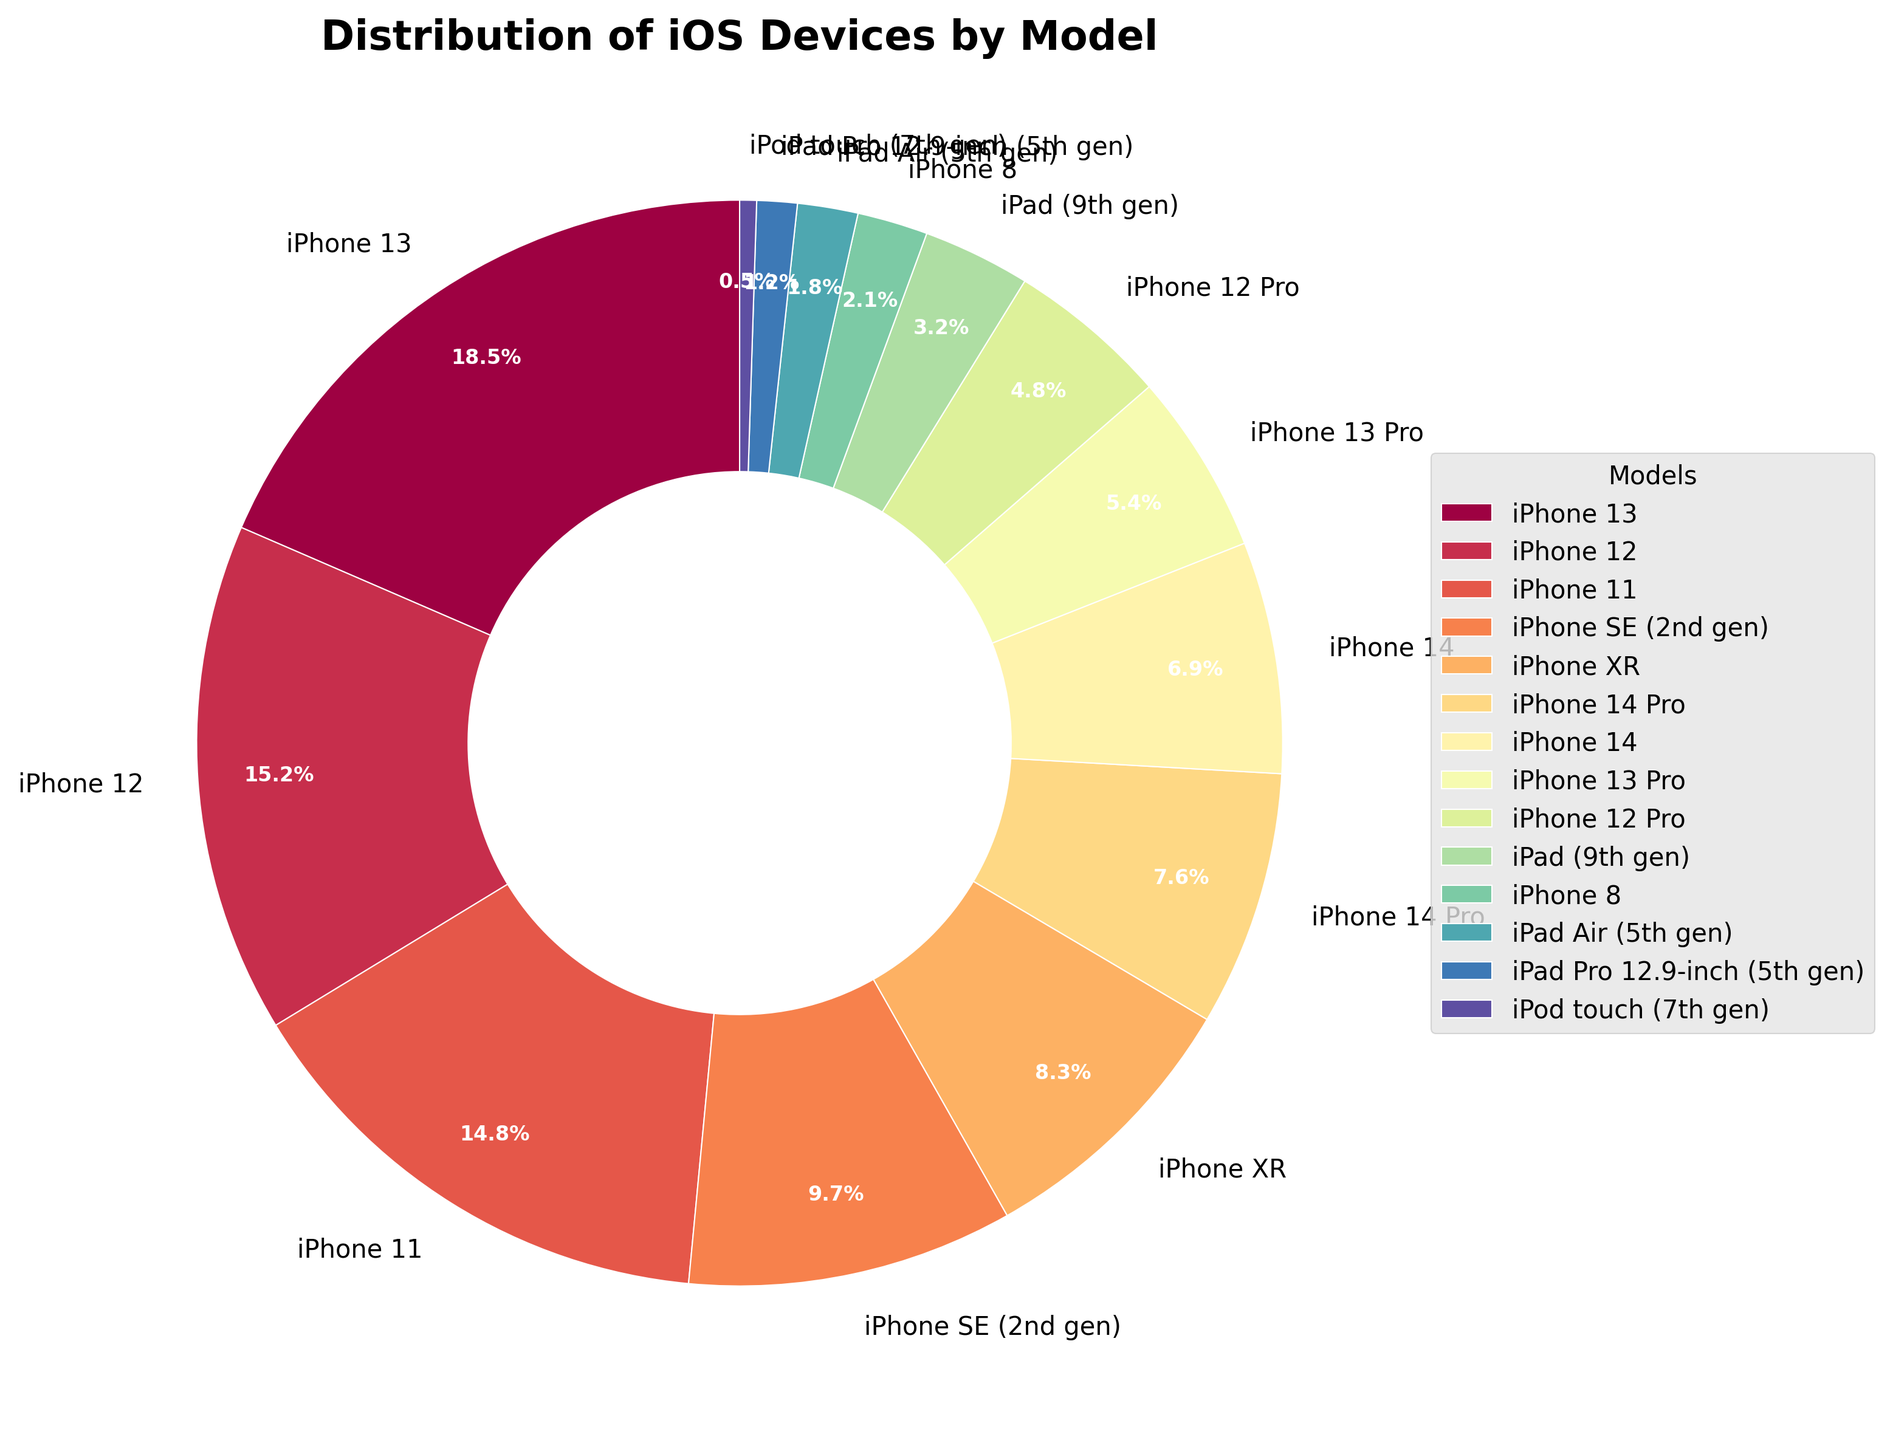Which iPhone model has the highest market share? The iPhone model with the highest market share can be identified by looking for the largest wedge in the pie chart. The largest wedge represents the iPhone 13 with 18.5%.
Answer: iPhone 13 What is the combined market share of iPhone 12 and iPhone 11? To find the combined market share, add the percentages of the iPhone 12 and iPhone 11. The iPhone 12 has 15.2%, and the iPhone 11 has 14.8%. So, 15.2% + 14.8% = 30%.
Answer: 30% Which model has a larger market share: iPhone SE (2nd gen) or iPhone XR? Compare the percentages of the iPhone SE (2nd gen) and iPhone XR. The iPhone SE (2nd gen) has 9.7%, and the iPhone XR has 8.3%. Since 9.7% > 8.3%, the iPhone SE (2nd gen) has a larger market share.
Answer: iPhone SE (2nd gen) What's the difference in market share between the iPhone 14 and iPhone 14 Pro? Subtract the market share of the iPhone 14 from the iPhone 14 Pro. The iPhone 14 has 6.9%, and the iPhone 14 Pro has 7.6%. So, 7.6% - 6.9% = 0.7%.
Answer: 0.7% How many models have a market share less than 5%? Check the percentages on the pie chart for models that have a market share smaller than 5%. The models are iPhone 12 Pro (4.8%), iPad (9th gen) (3.2%), iPhone 8 (2.1%), iPad Air (5th gen) (1.8%), iPad Pro 12.9-inch (5th gen) (1.2%), and iPod touch (7th gen) (0.5%). There are 6 models in total.
Answer: 6 Which iPhone model is shown with the smallest wedge in the pie chart? The smallest wedge on the pie chart corresponds to the smallest percentage. The model with the smallest percentage is the iPod touch (7th gen) with 0.5%.
Answer: iPod touch (7th gen) What is the total market share of all iPhone models that start with "iPhone 13”? Sum the market shares of all models that start with "iPhone 13". They are iPhone 13 (18.5%) and iPhone 13 Pro (5.4%). Adding these gives 18.5% + 5.4% = 23.9%.
Answer: 23.9% Which iPad model has a higher market share: iPad (9th gen) or iPad Air (5th gen)? Compare the percentages of iPad (9th gen) and iPad Air (5th gen). The iPad (9th gen) has 3.2% and the iPad Air (5th gen) has 1.8%. Since 3.2% > 1.8%, the iPad (9th gen) has a higher market share.
Answer: iPad (9th gen) What is the sum of the market shares of all iPad models shown? Add the percentages of all iPad models. These are iPad (9th gen) (3.2%), iPad Air (5th gen) (1.8%), and iPad Pro 12.9-inch (5th gen) (1.2%). So, 3.2% + 1.8% + 1.2% = 6.2%.
Answer: 6.2% 